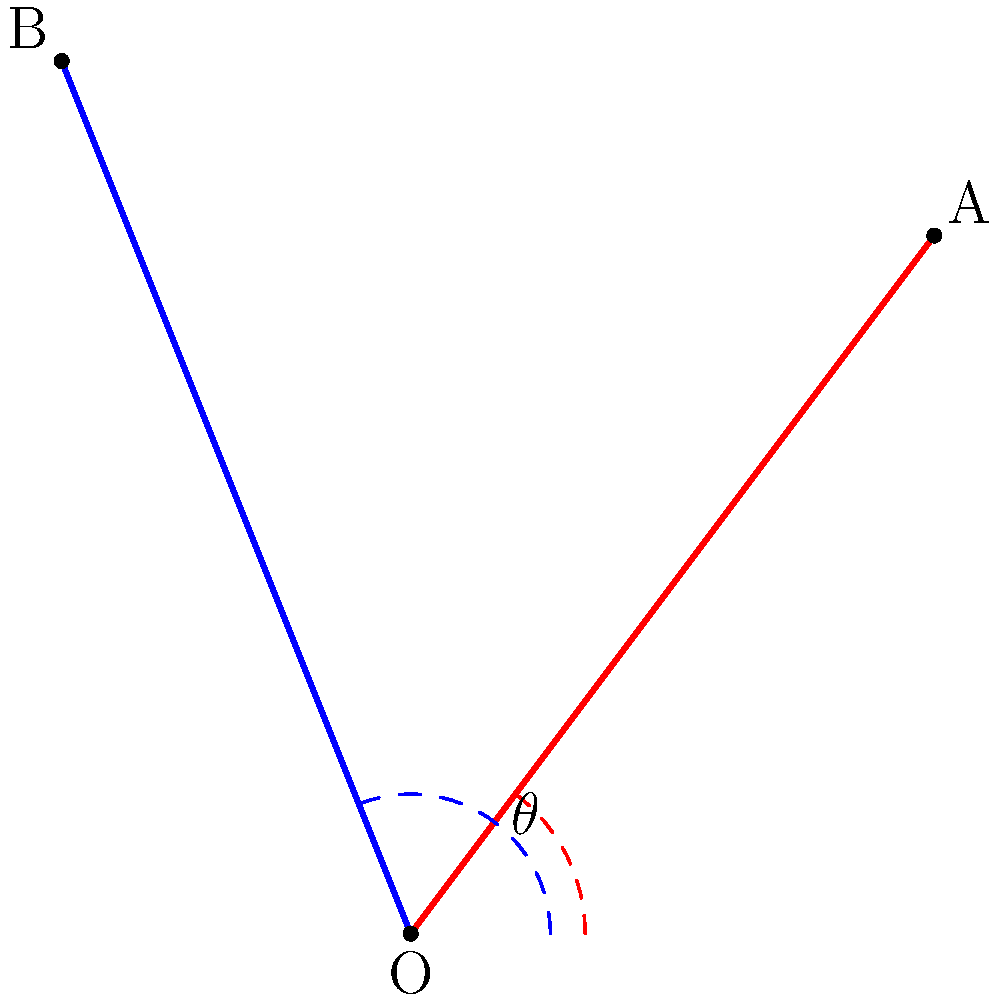On a movie set, two spotlights are positioned at points A and B, both directed towards point O where an actor is standing. The angle between the two spotlights is represented by $\theta$. If the coordinates of A are (3,4) and B are (-2,5) relative to O at (0,0), what is the value of $\theta$ in degrees? To find the angle between the two spotlights, we can follow these steps:

1) First, we need to calculate the vectors $\vec{OA}$ and $\vec{OB}$:
   $\vec{OA} = (3,4)$
   $\vec{OB} = (-2,5)$

2) The angle between these vectors can be found using the dot product formula:
   $$\cos \theta = \frac{\vec{OA} \cdot \vec{OB}}{|\vec{OA}||\vec{OB}|}$$

3) Calculate the dot product $\vec{OA} \cdot \vec{OB}$:
   $(3)(-2) + (4)(5) = -6 + 20 = 14$

4) Calculate the magnitudes:
   $|\vec{OA}| = \sqrt{3^2 + 4^2} = \sqrt{25} = 5$
   $|\vec{OB}| = \sqrt{(-2)^2 + 5^2} = \sqrt{29}$

5) Substitute into the formula:
   $$\cos \theta = \frac{14}{5\sqrt{29}}$$

6) Take the inverse cosine (arccos) of both sides:
   $$\theta = \arccos(\frac{14}{5\sqrt{29}})$$

7) Calculate this value and convert to degrees:
   $\theta \approx 53.13°$
Answer: $53.13°$ 